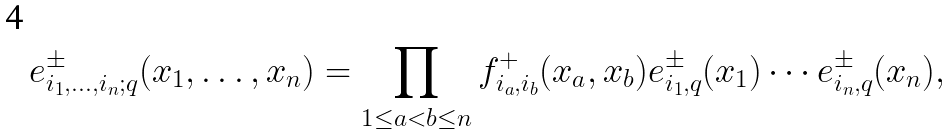Convert formula to latex. <formula><loc_0><loc_0><loc_500><loc_500>e _ { i _ { 1 } , \dots , i _ { n } ; q } ^ { \pm } ( x _ { 1 } , \dots , x _ { n } ) = \prod _ { 1 \leq a < b \leq n } f _ { i _ { a } , i _ { b } } ^ { + } ( x _ { a } , x _ { b } ) e _ { i _ { 1 } , q } ^ { \pm } ( x _ { 1 } ) \cdots e _ { i _ { n } , q } ^ { \pm } ( x _ { n } ) ,</formula> 